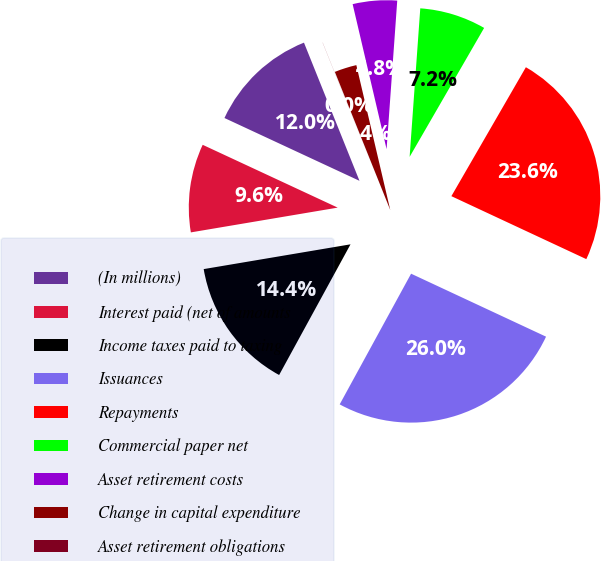Convert chart. <chart><loc_0><loc_0><loc_500><loc_500><pie_chart><fcel>(In millions)<fcel>Interest paid (net of amounts<fcel>Income taxes paid to taxing<fcel>Issuances<fcel>Repayments<fcel>Commercial paper net<fcel>Asset retirement costs<fcel>Change in capital expenditure<fcel>Asset retirement obligations<nl><fcel>11.99%<fcel>9.59%<fcel>14.38%<fcel>26.01%<fcel>23.61%<fcel>7.2%<fcel>4.8%<fcel>2.41%<fcel>0.01%<nl></chart> 